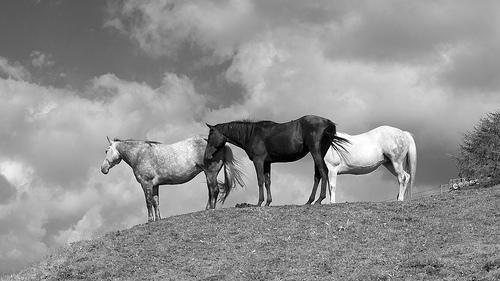How many horses are in the picture?
Give a very brief answer. 3. 